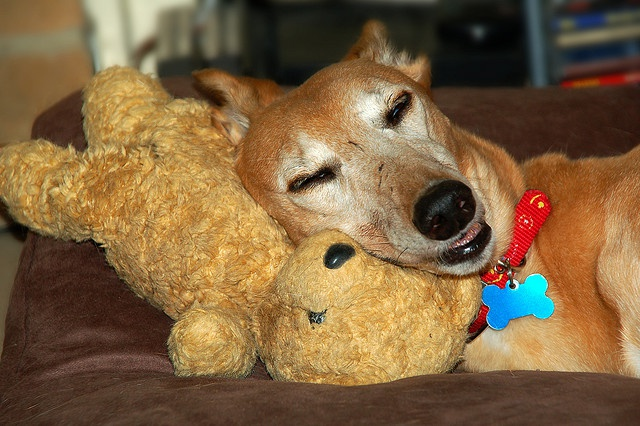Describe the objects in this image and their specific colors. I can see dog in olive, brown, tan, and gray tones and teddy bear in olive and tan tones in this image. 